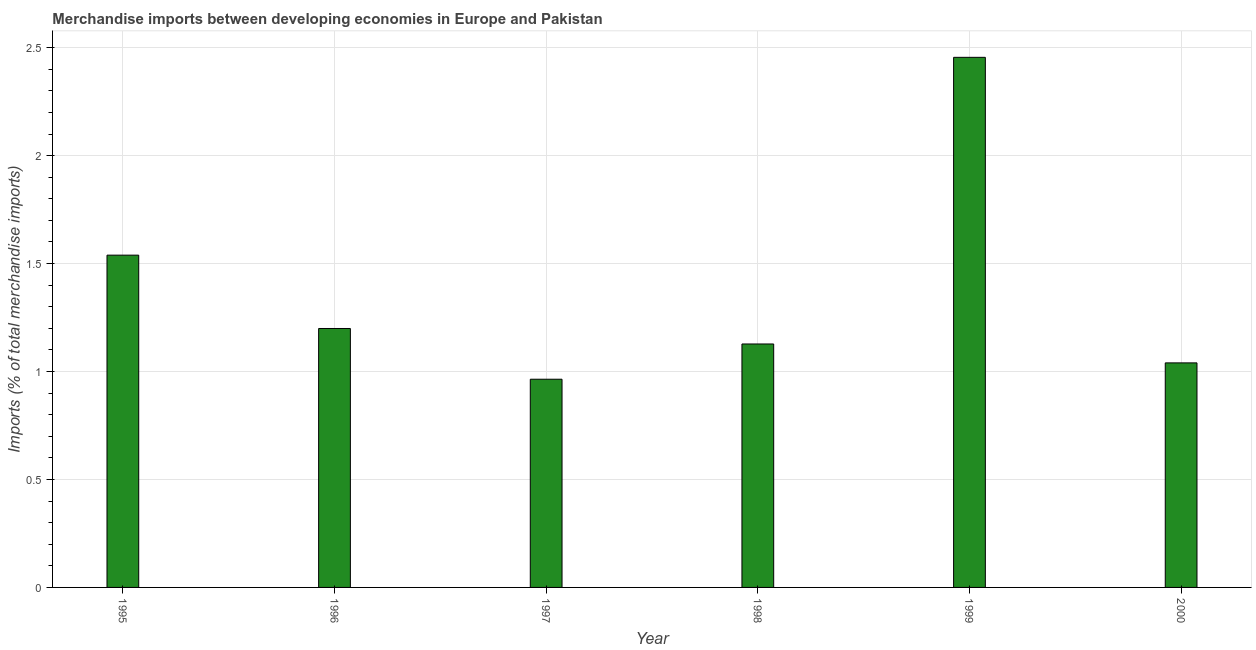Does the graph contain grids?
Keep it short and to the point. Yes. What is the title of the graph?
Provide a succinct answer. Merchandise imports between developing economies in Europe and Pakistan. What is the label or title of the Y-axis?
Provide a succinct answer. Imports (% of total merchandise imports). What is the merchandise imports in 1997?
Provide a succinct answer. 0.96. Across all years, what is the maximum merchandise imports?
Make the answer very short. 2.46. Across all years, what is the minimum merchandise imports?
Ensure brevity in your answer.  0.96. In which year was the merchandise imports maximum?
Provide a succinct answer. 1999. What is the sum of the merchandise imports?
Ensure brevity in your answer.  8.33. What is the difference between the merchandise imports in 1996 and 1999?
Make the answer very short. -1.26. What is the average merchandise imports per year?
Your response must be concise. 1.39. What is the median merchandise imports?
Your answer should be compact. 1.16. In how many years, is the merchandise imports greater than 1.1 %?
Ensure brevity in your answer.  4. What is the ratio of the merchandise imports in 1996 to that in 1997?
Make the answer very short. 1.24. What is the difference between the highest and the second highest merchandise imports?
Provide a succinct answer. 0.92. Is the sum of the merchandise imports in 1996 and 2000 greater than the maximum merchandise imports across all years?
Provide a succinct answer. No. What is the difference between the highest and the lowest merchandise imports?
Keep it short and to the point. 1.49. Are all the bars in the graph horizontal?
Ensure brevity in your answer.  No. How many years are there in the graph?
Your answer should be compact. 6. What is the difference between two consecutive major ticks on the Y-axis?
Offer a very short reply. 0.5. What is the Imports (% of total merchandise imports) in 1995?
Keep it short and to the point. 1.54. What is the Imports (% of total merchandise imports) of 1996?
Ensure brevity in your answer.  1.2. What is the Imports (% of total merchandise imports) in 1997?
Make the answer very short. 0.96. What is the Imports (% of total merchandise imports) of 1998?
Provide a succinct answer. 1.13. What is the Imports (% of total merchandise imports) in 1999?
Offer a terse response. 2.46. What is the Imports (% of total merchandise imports) in 2000?
Offer a terse response. 1.04. What is the difference between the Imports (% of total merchandise imports) in 1995 and 1996?
Your answer should be very brief. 0.34. What is the difference between the Imports (% of total merchandise imports) in 1995 and 1997?
Your answer should be very brief. 0.57. What is the difference between the Imports (% of total merchandise imports) in 1995 and 1998?
Keep it short and to the point. 0.41. What is the difference between the Imports (% of total merchandise imports) in 1995 and 1999?
Your answer should be very brief. -0.92. What is the difference between the Imports (% of total merchandise imports) in 1995 and 2000?
Your answer should be compact. 0.5. What is the difference between the Imports (% of total merchandise imports) in 1996 and 1997?
Your response must be concise. 0.24. What is the difference between the Imports (% of total merchandise imports) in 1996 and 1998?
Your answer should be compact. 0.07. What is the difference between the Imports (% of total merchandise imports) in 1996 and 1999?
Offer a terse response. -1.26. What is the difference between the Imports (% of total merchandise imports) in 1996 and 2000?
Offer a very short reply. 0.16. What is the difference between the Imports (% of total merchandise imports) in 1997 and 1998?
Make the answer very short. -0.16. What is the difference between the Imports (% of total merchandise imports) in 1997 and 1999?
Your answer should be very brief. -1.49. What is the difference between the Imports (% of total merchandise imports) in 1997 and 2000?
Offer a terse response. -0.08. What is the difference between the Imports (% of total merchandise imports) in 1998 and 1999?
Offer a terse response. -1.33. What is the difference between the Imports (% of total merchandise imports) in 1998 and 2000?
Ensure brevity in your answer.  0.09. What is the difference between the Imports (% of total merchandise imports) in 1999 and 2000?
Give a very brief answer. 1.42. What is the ratio of the Imports (% of total merchandise imports) in 1995 to that in 1996?
Offer a terse response. 1.28. What is the ratio of the Imports (% of total merchandise imports) in 1995 to that in 1997?
Provide a short and direct response. 1.6. What is the ratio of the Imports (% of total merchandise imports) in 1995 to that in 1998?
Offer a very short reply. 1.36. What is the ratio of the Imports (% of total merchandise imports) in 1995 to that in 1999?
Your response must be concise. 0.63. What is the ratio of the Imports (% of total merchandise imports) in 1995 to that in 2000?
Your answer should be very brief. 1.48. What is the ratio of the Imports (% of total merchandise imports) in 1996 to that in 1997?
Make the answer very short. 1.24. What is the ratio of the Imports (% of total merchandise imports) in 1996 to that in 1998?
Your answer should be very brief. 1.06. What is the ratio of the Imports (% of total merchandise imports) in 1996 to that in 1999?
Provide a succinct answer. 0.49. What is the ratio of the Imports (% of total merchandise imports) in 1996 to that in 2000?
Your answer should be very brief. 1.15. What is the ratio of the Imports (% of total merchandise imports) in 1997 to that in 1998?
Offer a very short reply. 0.85. What is the ratio of the Imports (% of total merchandise imports) in 1997 to that in 1999?
Keep it short and to the point. 0.39. What is the ratio of the Imports (% of total merchandise imports) in 1997 to that in 2000?
Your answer should be compact. 0.93. What is the ratio of the Imports (% of total merchandise imports) in 1998 to that in 1999?
Keep it short and to the point. 0.46. What is the ratio of the Imports (% of total merchandise imports) in 1998 to that in 2000?
Give a very brief answer. 1.08. What is the ratio of the Imports (% of total merchandise imports) in 1999 to that in 2000?
Offer a terse response. 2.36. 